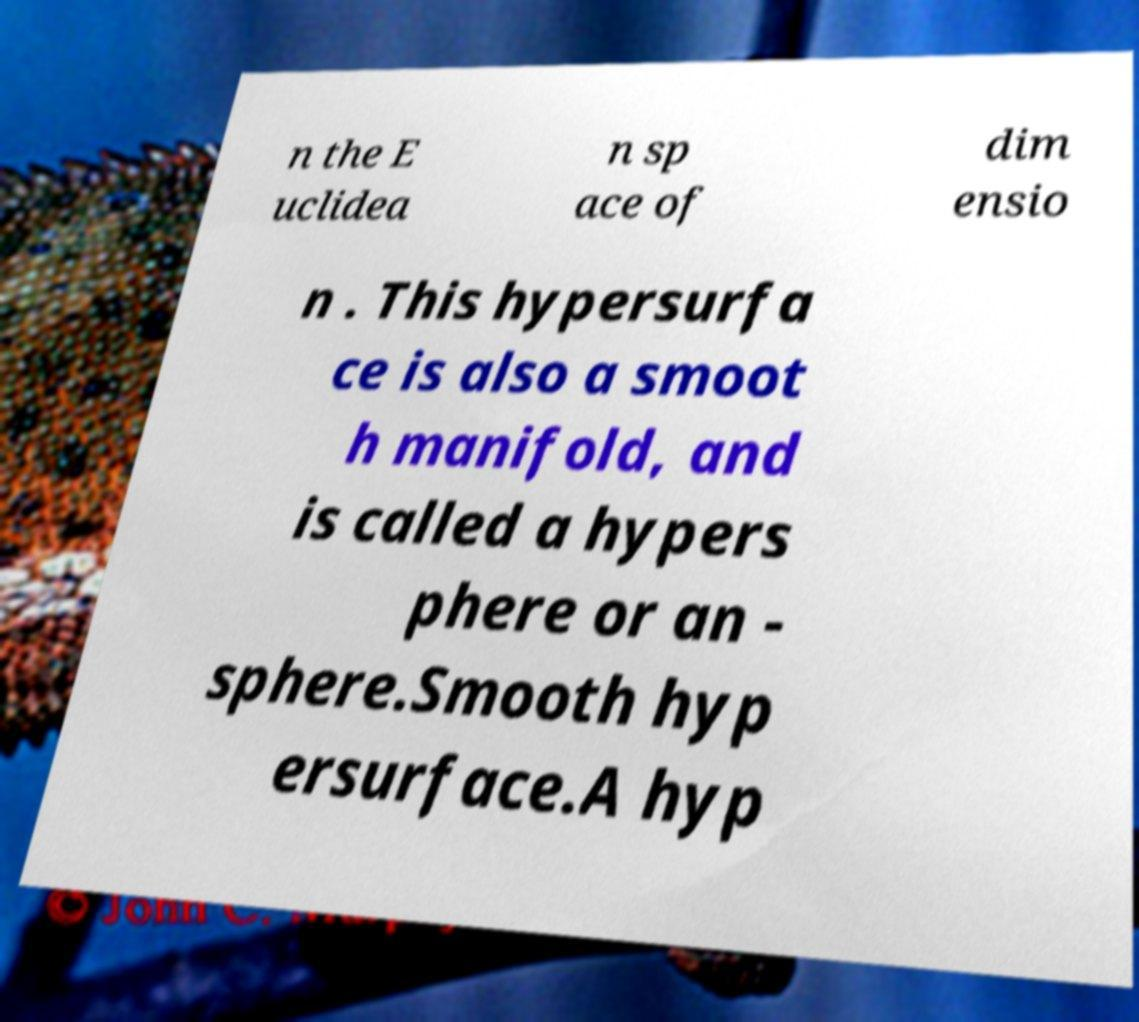Please identify and transcribe the text found in this image. n the E uclidea n sp ace of dim ensio n . This hypersurfa ce is also a smoot h manifold, and is called a hypers phere or an - sphere.Smooth hyp ersurface.A hyp 